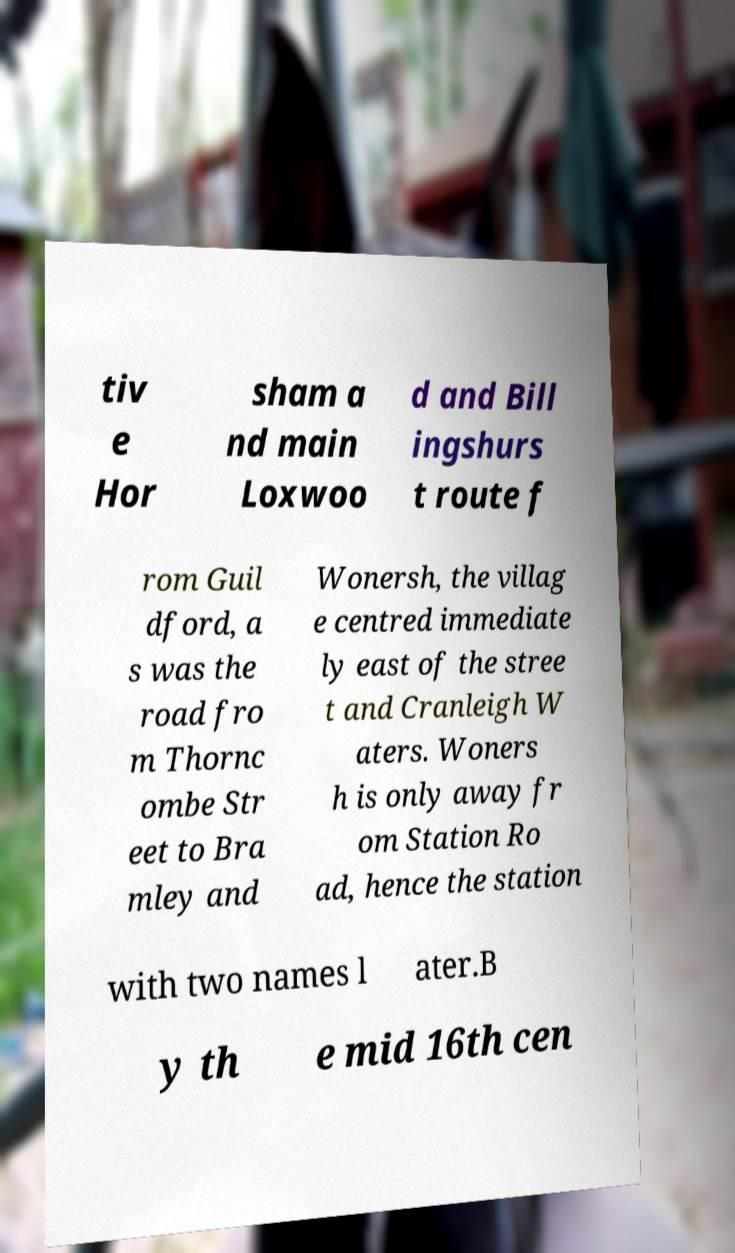Could you extract and type out the text from this image? tiv e Hor sham a nd main Loxwoo d and Bill ingshurs t route f rom Guil dford, a s was the road fro m Thornc ombe Str eet to Bra mley and Wonersh, the villag e centred immediate ly east of the stree t and Cranleigh W aters. Woners h is only away fr om Station Ro ad, hence the station with two names l ater.B y th e mid 16th cen 